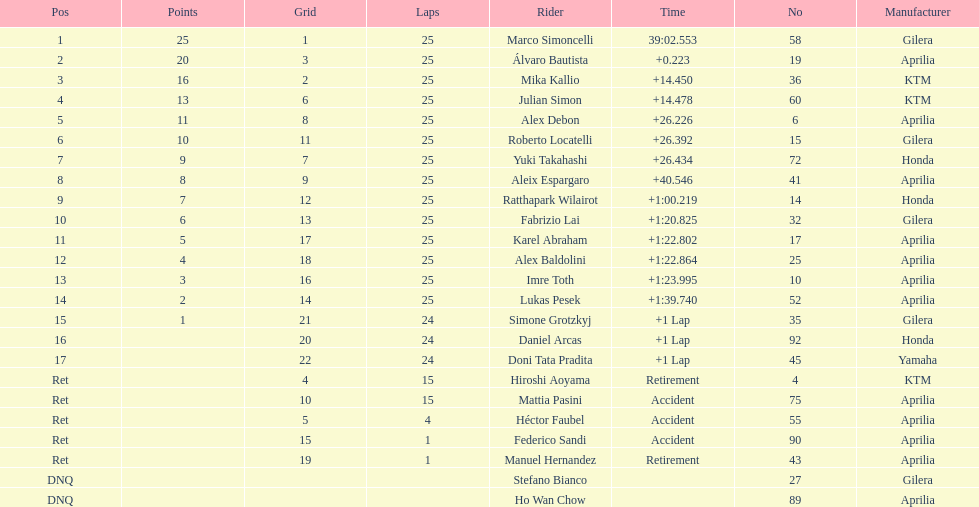The total amount of riders who did not qualify 2. 